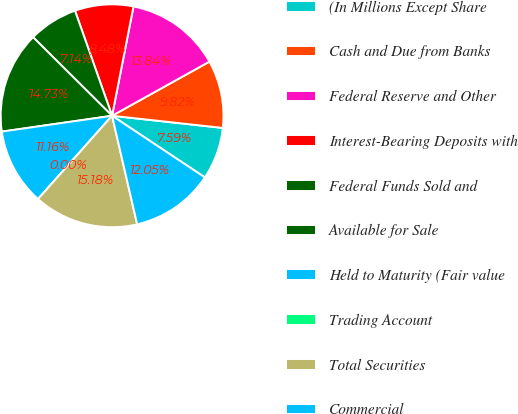Convert chart to OTSL. <chart><loc_0><loc_0><loc_500><loc_500><pie_chart><fcel>(In Millions Except Share<fcel>Cash and Due from Banks<fcel>Federal Reserve and Other<fcel>Interest-Bearing Deposits with<fcel>Federal Funds Sold and<fcel>Available for Sale<fcel>Held to Maturity (Fair value<fcel>Trading Account<fcel>Total Securities<fcel>Commercial<nl><fcel>7.59%<fcel>9.82%<fcel>13.84%<fcel>8.48%<fcel>7.14%<fcel>14.73%<fcel>11.16%<fcel>0.0%<fcel>15.18%<fcel>12.05%<nl></chart> 